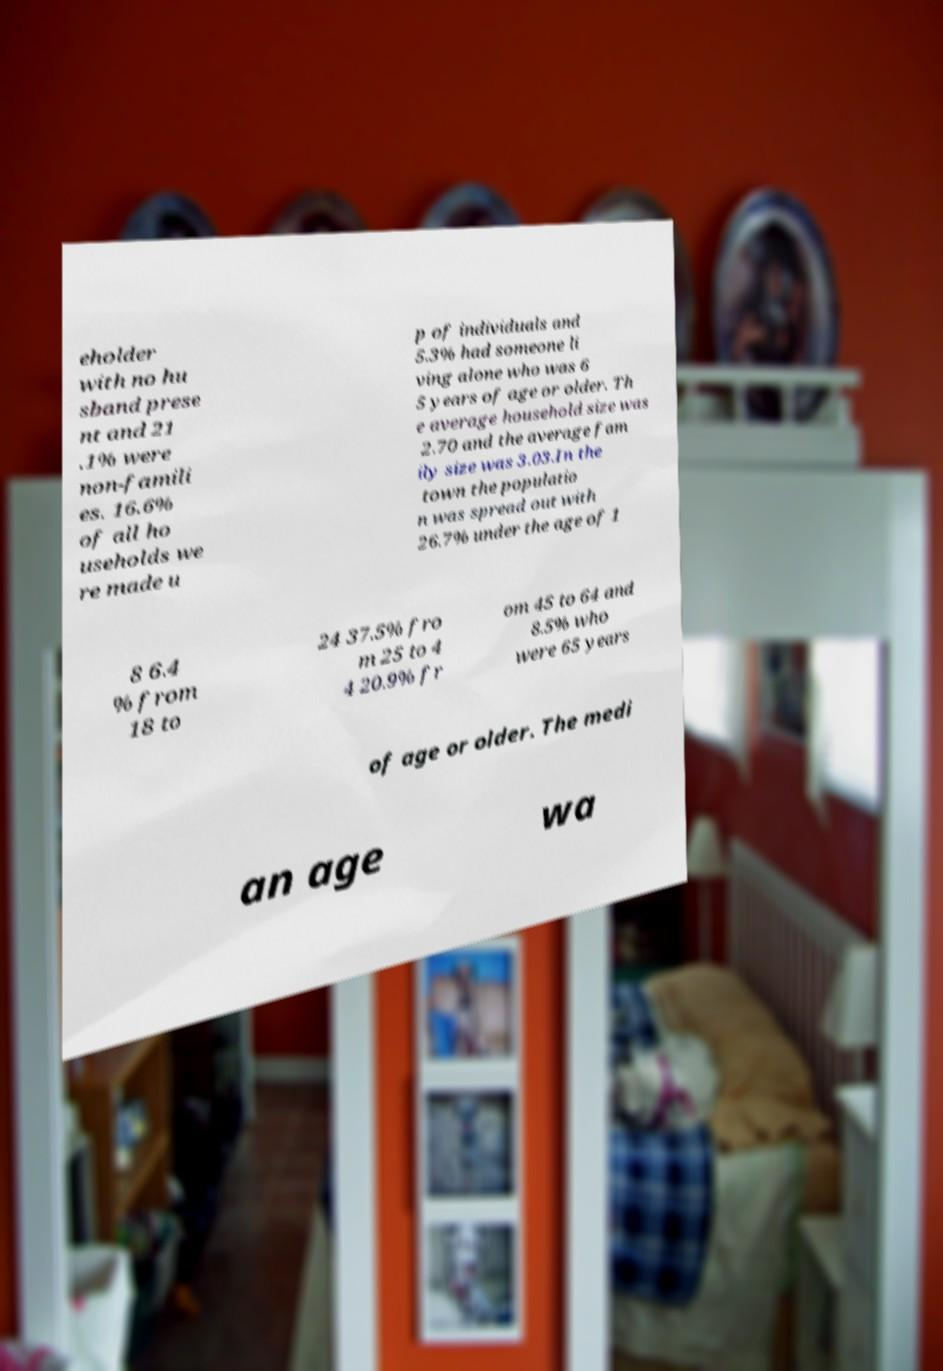Please read and relay the text visible in this image. What does it say? eholder with no hu sband prese nt and 21 .1% were non-famili es. 16.6% of all ho useholds we re made u p of individuals and 5.3% had someone li ving alone who was 6 5 years of age or older. Th e average household size was 2.70 and the average fam ily size was 3.03.In the town the populatio n was spread out with 26.7% under the age of 1 8 6.4 % from 18 to 24 37.5% fro m 25 to 4 4 20.9% fr om 45 to 64 and 8.5% who were 65 years of age or older. The medi an age wa 